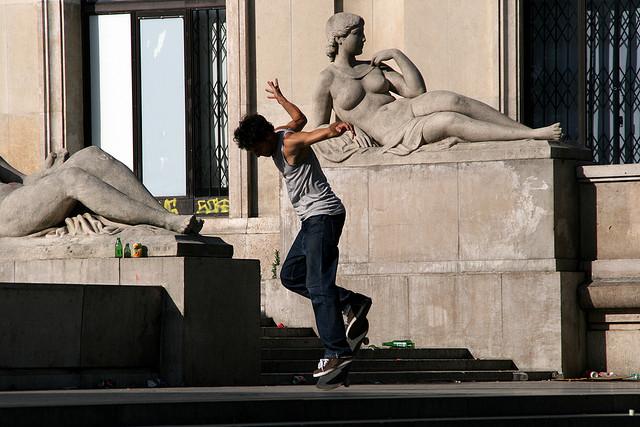Does the shirt have sleeves?
Give a very brief answer. No. What is the boy doing?
Write a very short answer. Skateboarding. How many breasts?
Short answer required. 2. What is the woman doing?
Answer briefly. Skateboarding. 